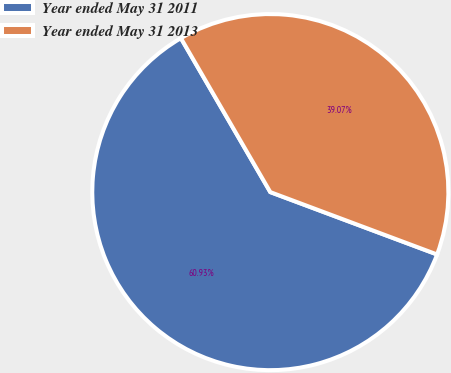Convert chart. <chart><loc_0><loc_0><loc_500><loc_500><pie_chart><fcel>Year ended May 31 2011<fcel>Year ended May 31 2013<nl><fcel>60.93%<fcel>39.07%<nl></chart> 